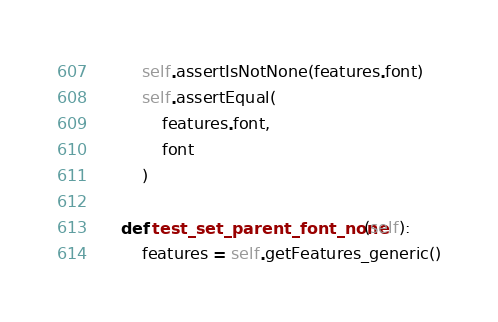<code> <loc_0><loc_0><loc_500><loc_500><_Python_>        self.assertIsNotNone(features.font)
        self.assertEqual(
            features.font,
            font
        )

    def test_set_parent_font_none(self):
        features = self.getFeatures_generic()</code> 